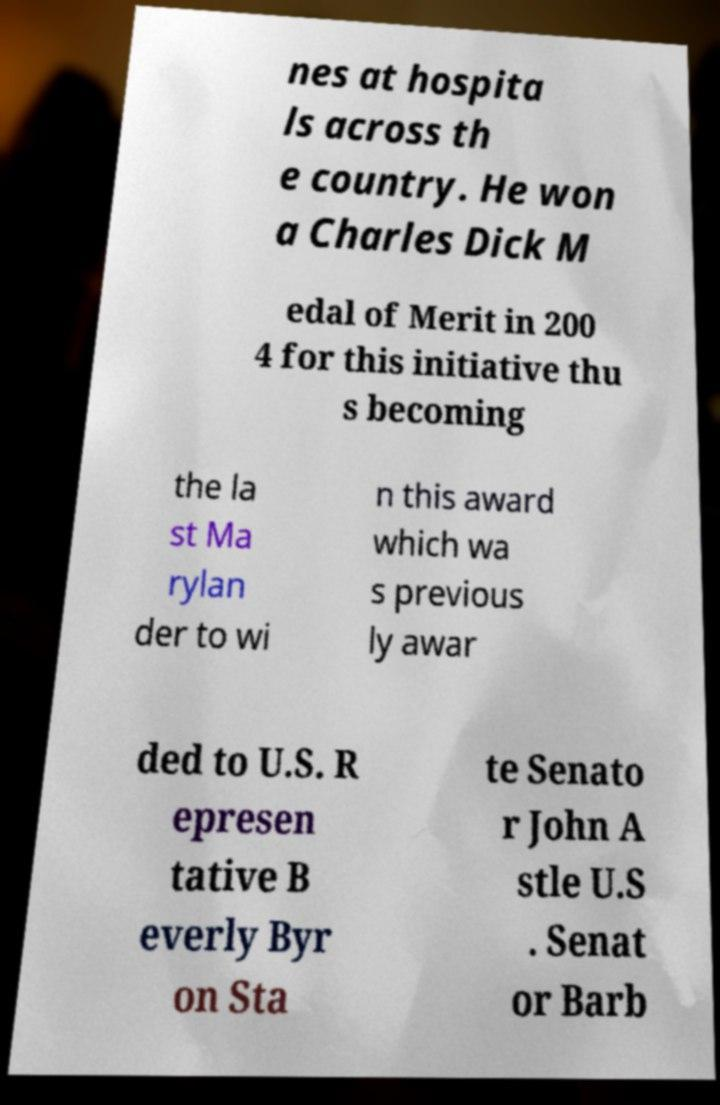Please identify and transcribe the text found in this image. nes at hospita ls across th e country. He won a Charles Dick M edal of Merit in 200 4 for this initiative thu s becoming the la st Ma rylan der to wi n this award which wa s previous ly awar ded to U.S. R epresen tative B everly Byr on Sta te Senato r John A stle U.S . Senat or Barb 